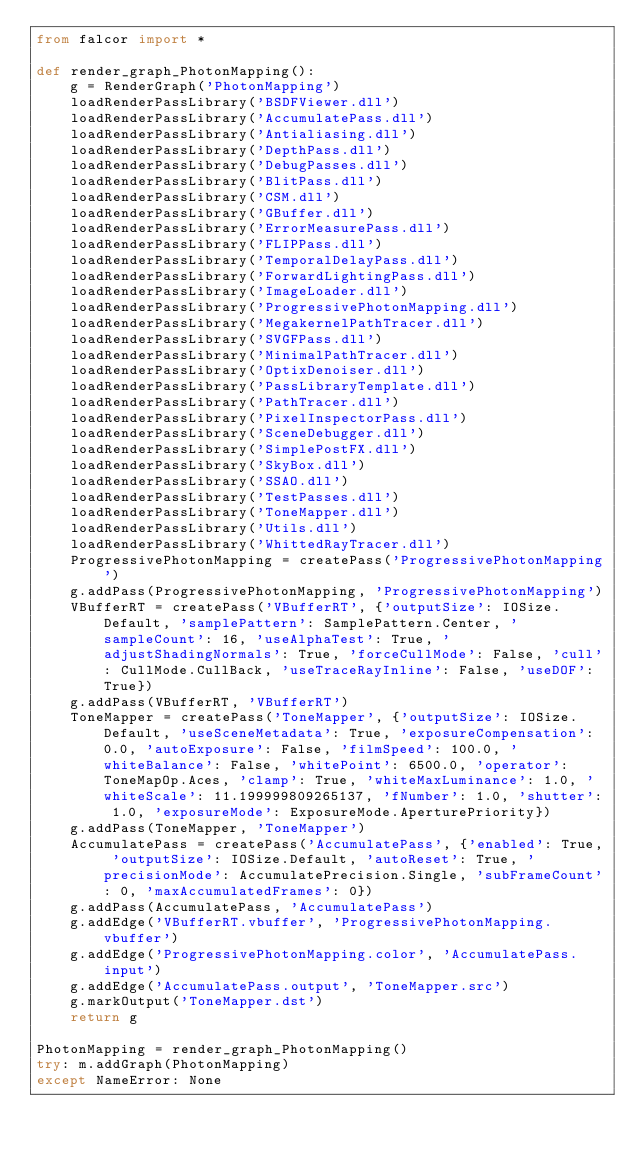Convert code to text. <code><loc_0><loc_0><loc_500><loc_500><_Python_>from falcor import *

def render_graph_PhotonMapping():
    g = RenderGraph('PhotonMapping')
    loadRenderPassLibrary('BSDFViewer.dll')
    loadRenderPassLibrary('AccumulatePass.dll')
    loadRenderPassLibrary('Antialiasing.dll')
    loadRenderPassLibrary('DepthPass.dll')
    loadRenderPassLibrary('DebugPasses.dll')
    loadRenderPassLibrary('BlitPass.dll')
    loadRenderPassLibrary('CSM.dll')
    loadRenderPassLibrary('GBuffer.dll')
    loadRenderPassLibrary('ErrorMeasurePass.dll')
    loadRenderPassLibrary('FLIPPass.dll')
    loadRenderPassLibrary('TemporalDelayPass.dll')
    loadRenderPassLibrary('ForwardLightingPass.dll')
    loadRenderPassLibrary('ImageLoader.dll')
    loadRenderPassLibrary('ProgressivePhotonMapping.dll')
    loadRenderPassLibrary('MegakernelPathTracer.dll')
    loadRenderPassLibrary('SVGFPass.dll')
    loadRenderPassLibrary('MinimalPathTracer.dll')
    loadRenderPassLibrary('OptixDenoiser.dll')
    loadRenderPassLibrary('PassLibraryTemplate.dll')
    loadRenderPassLibrary('PathTracer.dll')
    loadRenderPassLibrary('PixelInspectorPass.dll')
    loadRenderPassLibrary('SceneDebugger.dll')
    loadRenderPassLibrary('SimplePostFX.dll')
    loadRenderPassLibrary('SkyBox.dll')
    loadRenderPassLibrary('SSAO.dll')
    loadRenderPassLibrary('TestPasses.dll')
    loadRenderPassLibrary('ToneMapper.dll')
    loadRenderPassLibrary('Utils.dll')
    loadRenderPassLibrary('WhittedRayTracer.dll')
    ProgressivePhotonMapping = createPass('ProgressivePhotonMapping')
    g.addPass(ProgressivePhotonMapping, 'ProgressivePhotonMapping')
    VBufferRT = createPass('VBufferRT', {'outputSize': IOSize.Default, 'samplePattern': SamplePattern.Center, 'sampleCount': 16, 'useAlphaTest': True, 'adjustShadingNormals': True, 'forceCullMode': False, 'cull': CullMode.CullBack, 'useTraceRayInline': False, 'useDOF': True})
    g.addPass(VBufferRT, 'VBufferRT')
    ToneMapper = createPass('ToneMapper', {'outputSize': IOSize.Default, 'useSceneMetadata': True, 'exposureCompensation': 0.0, 'autoExposure': False, 'filmSpeed': 100.0, 'whiteBalance': False, 'whitePoint': 6500.0, 'operator': ToneMapOp.Aces, 'clamp': True, 'whiteMaxLuminance': 1.0, 'whiteScale': 11.199999809265137, 'fNumber': 1.0, 'shutter': 1.0, 'exposureMode': ExposureMode.AperturePriority})
    g.addPass(ToneMapper, 'ToneMapper')
    AccumulatePass = createPass('AccumulatePass', {'enabled': True, 'outputSize': IOSize.Default, 'autoReset': True, 'precisionMode': AccumulatePrecision.Single, 'subFrameCount': 0, 'maxAccumulatedFrames': 0})
    g.addPass(AccumulatePass, 'AccumulatePass')
    g.addEdge('VBufferRT.vbuffer', 'ProgressivePhotonMapping.vbuffer')
    g.addEdge('ProgressivePhotonMapping.color', 'AccumulatePass.input')
    g.addEdge('AccumulatePass.output', 'ToneMapper.src')
    g.markOutput('ToneMapper.dst')
    return g

PhotonMapping = render_graph_PhotonMapping()
try: m.addGraph(PhotonMapping)
except NameError: None
</code> 